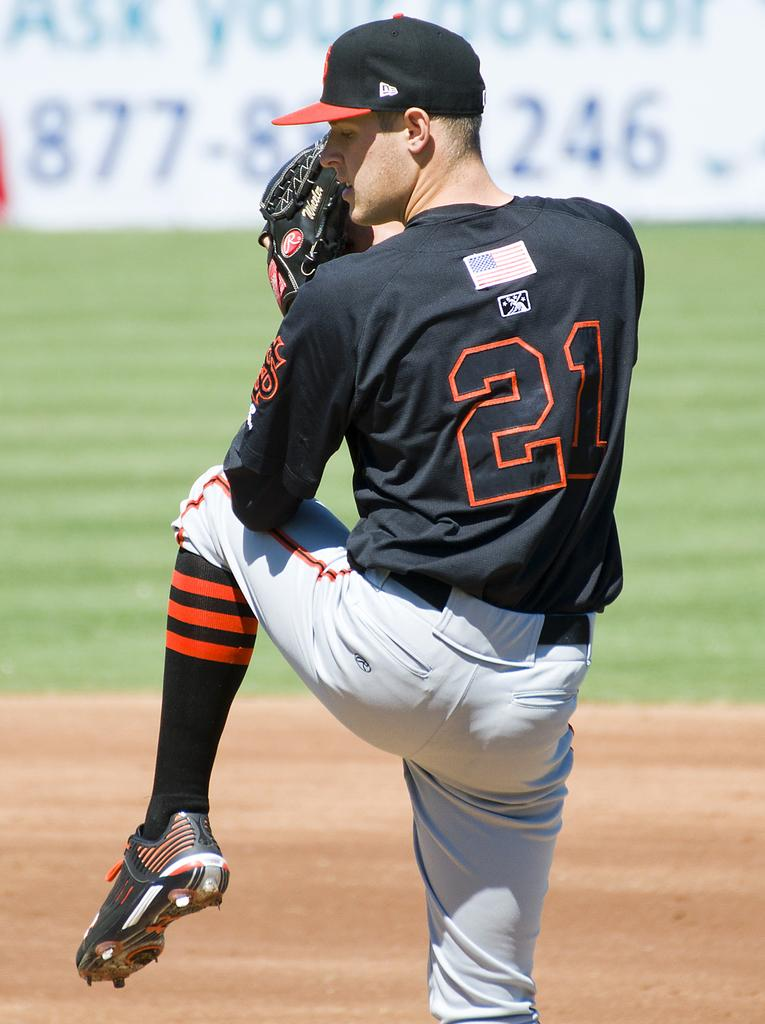<image>
Offer a succinct explanation of the picture presented. The number 21 baseball pitcher is in his wind up ready to pitch the ball. 